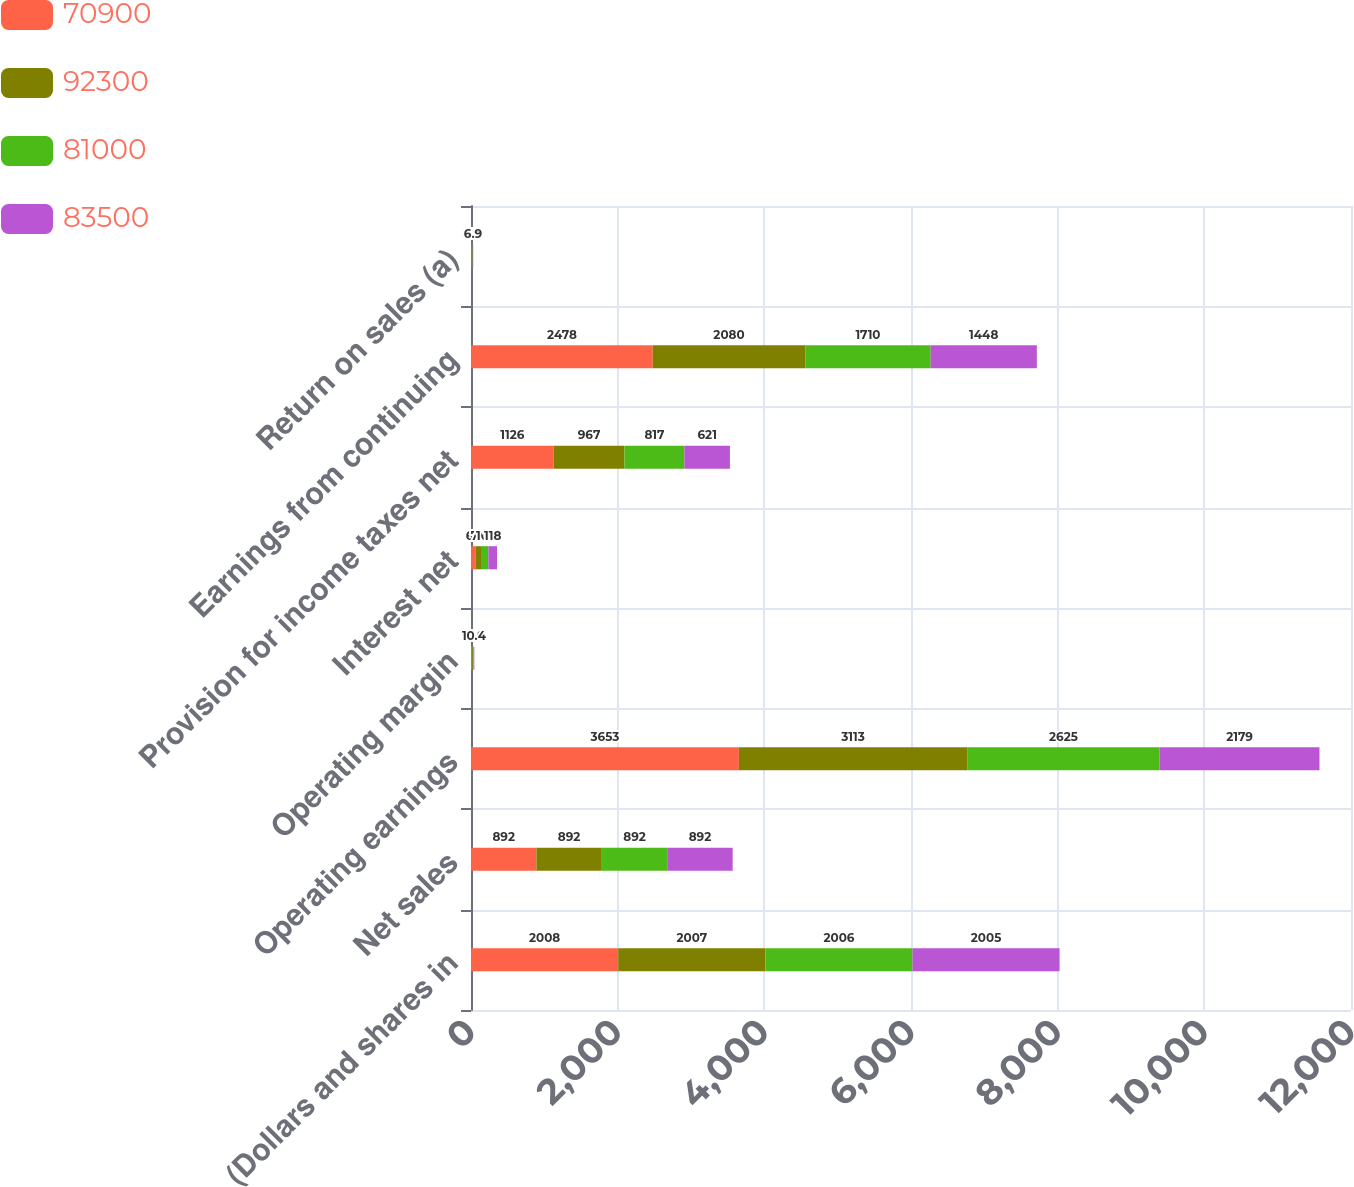Convert chart. <chart><loc_0><loc_0><loc_500><loc_500><stacked_bar_chart><ecel><fcel>(Dollars and shares in<fcel>Net sales<fcel>Operating earnings<fcel>Operating margin<fcel>Interest net<fcel>Provision for income taxes net<fcel>Earnings from continuing<fcel>Return on sales (a)<nl><fcel>70900<fcel>2008<fcel>892<fcel>3653<fcel>12.5<fcel>66<fcel>1126<fcel>2478<fcel>8.5<nl><fcel>92300<fcel>2007<fcel>892<fcel>3113<fcel>11.4<fcel>70<fcel>967<fcel>2080<fcel>7.6<nl><fcel>81000<fcel>2006<fcel>892<fcel>2625<fcel>10.9<fcel>101<fcel>817<fcel>1710<fcel>7.1<nl><fcel>83500<fcel>2005<fcel>892<fcel>2179<fcel>10.4<fcel>118<fcel>621<fcel>1448<fcel>6.9<nl></chart> 